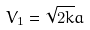<formula> <loc_0><loc_0><loc_500><loc_500>V _ { 1 } = \sqrt { 2 k } a</formula> 